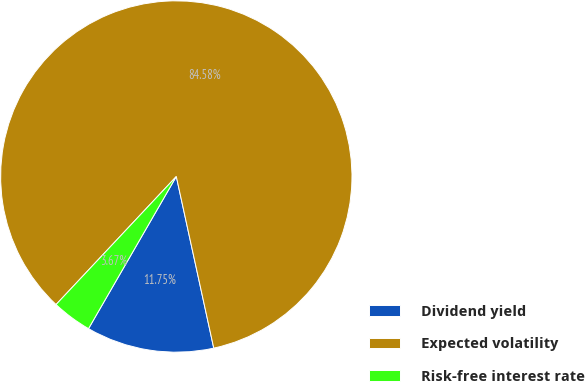<chart> <loc_0><loc_0><loc_500><loc_500><pie_chart><fcel>Dividend yield<fcel>Expected volatility<fcel>Risk-free interest rate<nl><fcel>11.75%<fcel>84.58%<fcel>3.67%<nl></chart> 